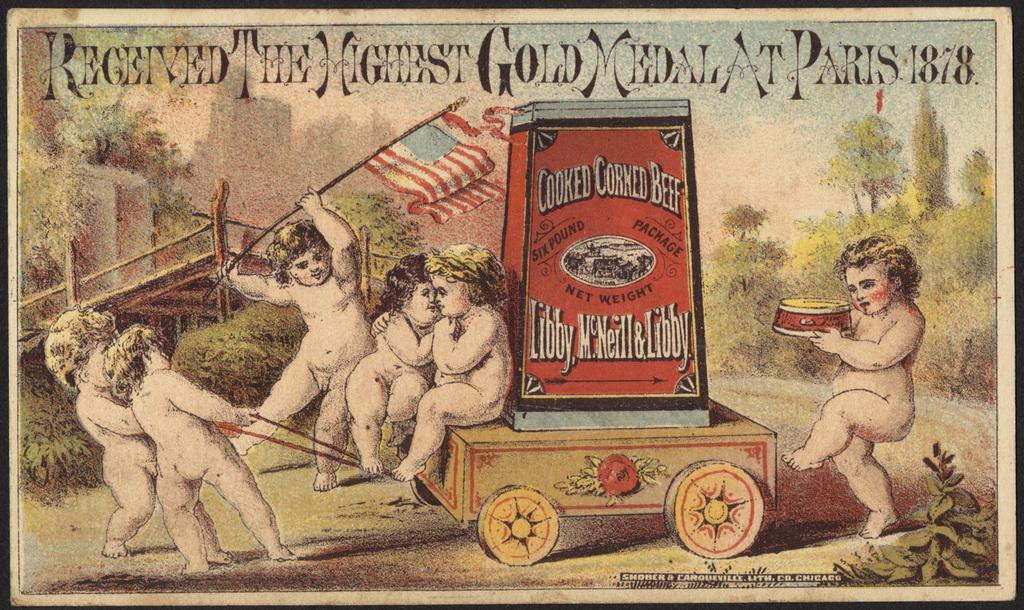Provide a one-sentence caption for the provided image. A poster includes cherubs pilling a wagon with a can of corned beef in it. 